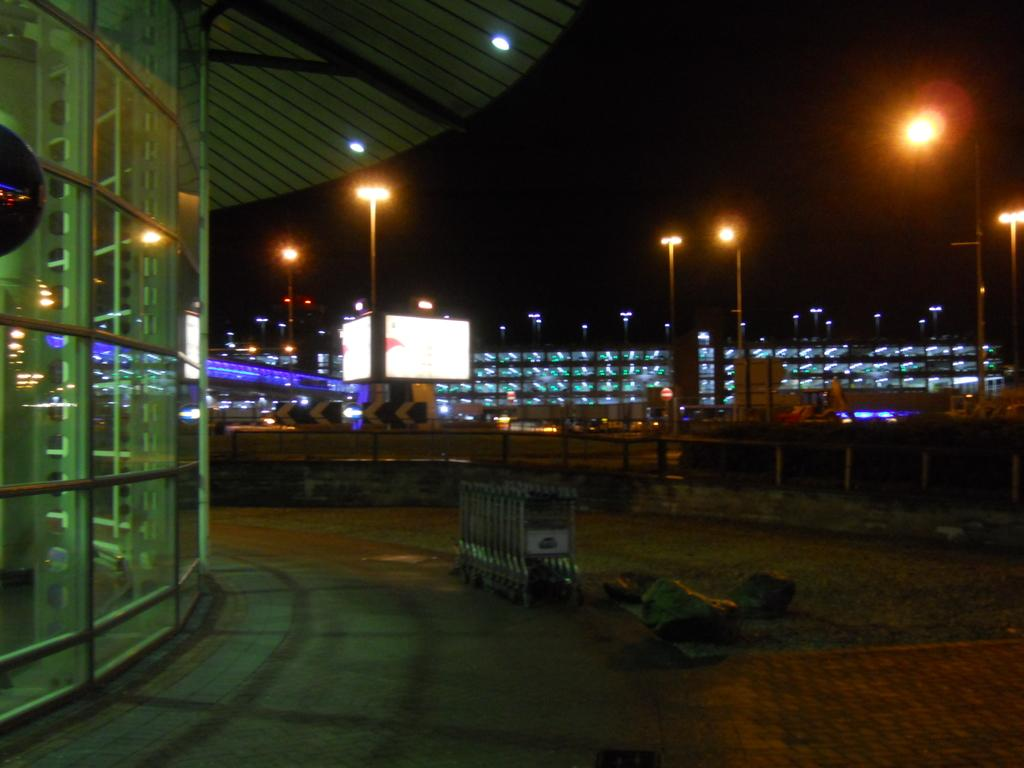What type of natural elements can be seen in the image? There are rocks and grass visible in the image. What man-made structures can be seen in the image? There is a vehicle, a fence, a building, and lights visible in the image. What can be seen in the background of the image? In the background, there is a hoarding, poles, lights, boards, and buildings. What type of skin condition can be seen on the rocks in the image? There is no skin condition present on the rocks in the image, as rocks do not have skin. Is there a mailbox visible in the image? No, there is no mailbox present in the image. Are there any horses visible in the image? No, there are no horses present in the image. 